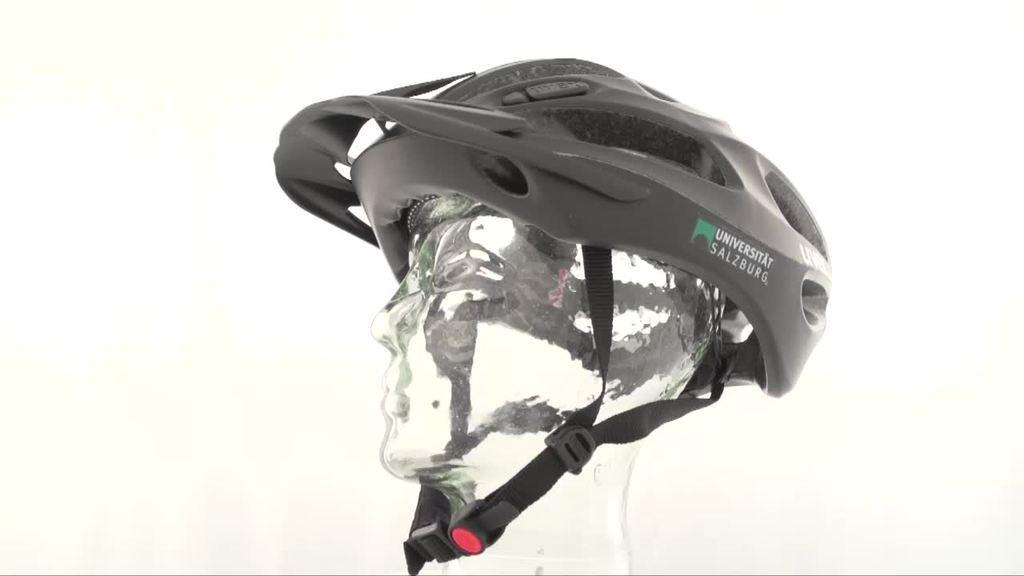Describe this image in one or two sentences. In this image I can see a mannequin which is made up of ice. On the top of it there is a helmet. 